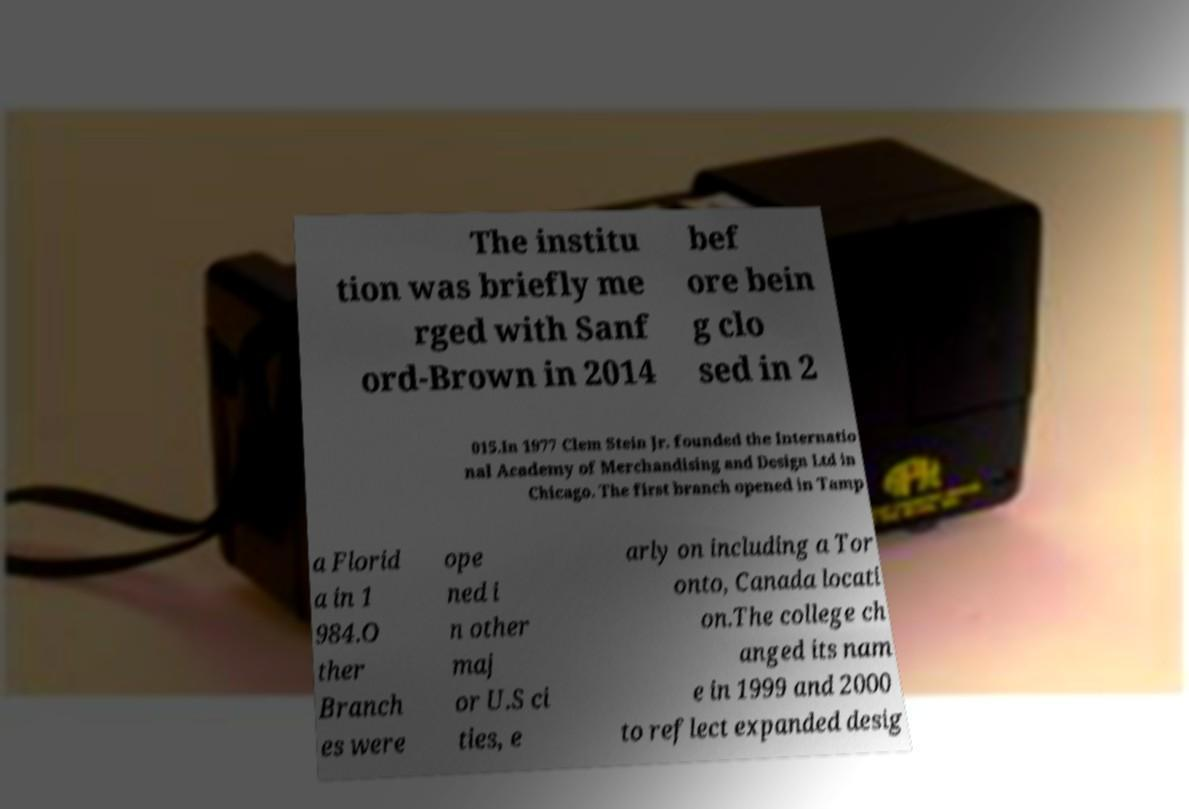Can you accurately transcribe the text from the provided image for me? The institu tion was briefly me rged with Sanf ord-Brown in 2014 bef ore bein g clo sed in 2 015.In 1977 Clem Stein Jr. founded the Internatio nal Academy of Merchandising and Design Ltd in Chicago. The first branch opened in Tamp a Florid a in 1 984.O ther Branch es were ope ned i n other maj or U.S ci ties, e arly on including a Tor onto, Canada locati on.The college ch anged its nam e in 1999 and 2000 to reflect expanded desig 